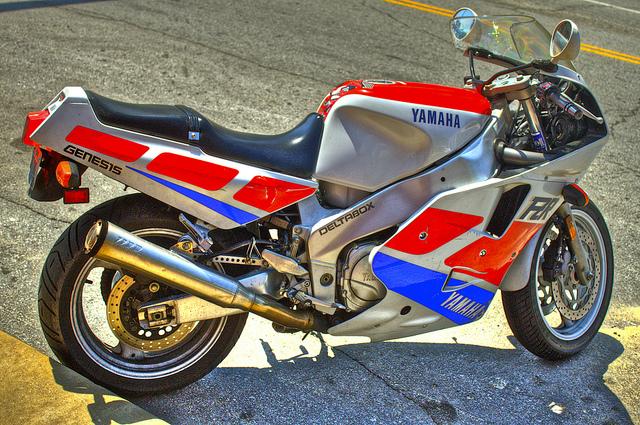Is this a Yamaha motorbike?
Keep it brief. Yes. What are the colors you see on the bike?
Concise answer only. Red silver blue. What model of bike is this?
Keep it brief. Yamaha. 